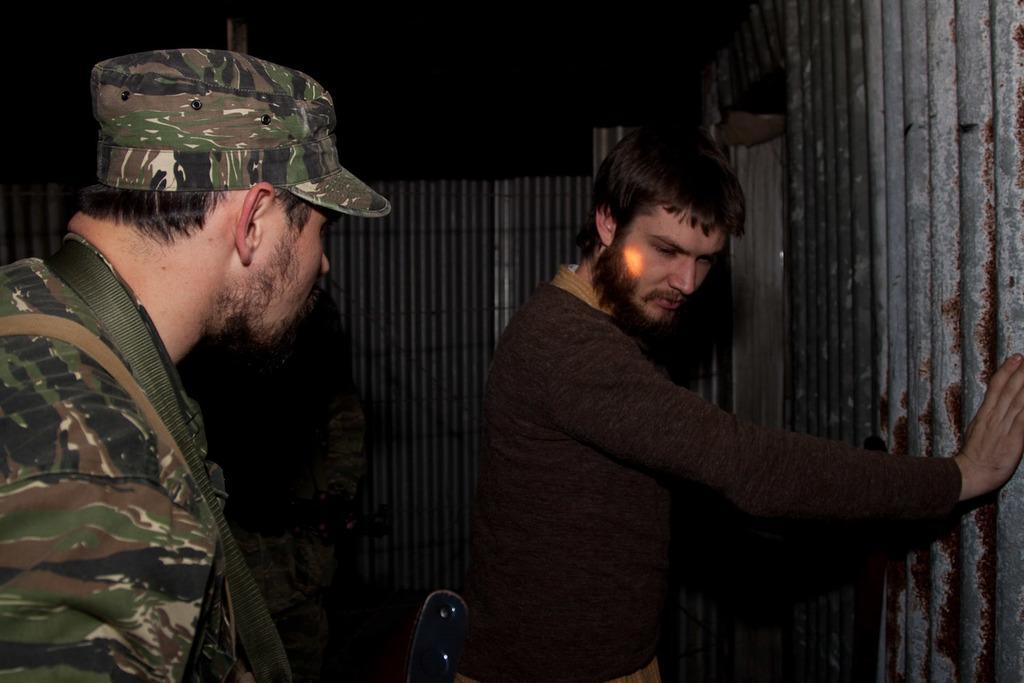In one or two sentences, can you explain what this image depicts? In this picture we can see two men standing here, a man on the left side wore a cap, we can see some sheets in the background. 